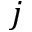Convert formula to latex. <formula><loc_0><loc_0><loc_500><loc_500>j</formula> 